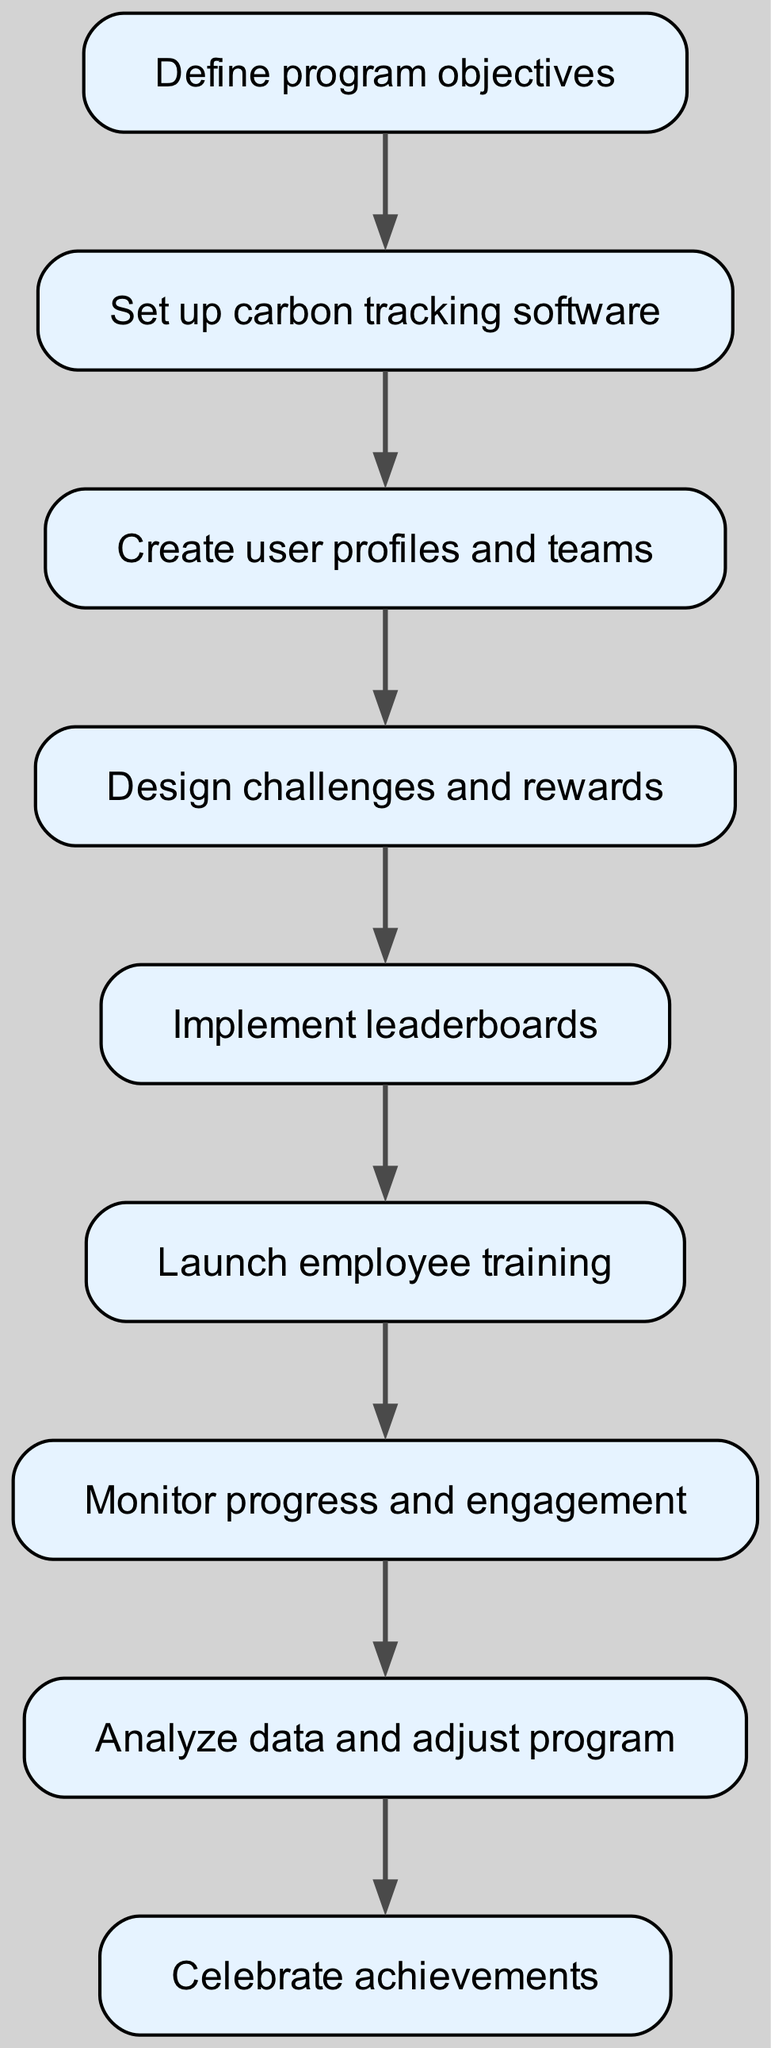What is the first step in the diagram? The first step in the diagram is labeled as "Define program objectives," which is the initial action to be taken in the process.
Answer: Define program objectives How many total steps are there in the diagram? By counting the steps listed in the diagram from the data provided, there are nine distinct steps in total outlined in the flow chart.
Answer: 9 What step comes after "Design challenges and rewards"? Following "Design challenges and rewards," the next step in the flow chart is "Implement leaderboards," indicating a progression in implementing the program.
Answer: Implement leaderboards What is the last action in the flow chart? The final action listed in the diagram is "Celebrate achievements," which is where the flow chart leads to after completing the prior steps.
Answer: Celebrate achievements Which step does directly follow "Monitor progress and engagement"? The step that comes directly after "Monitor progress and engagement" is "Analyze data and adjust program," meaning adjustments will be made based on the gathered progress.
Answer: Analyze data and adjust program What are the two consecutive steps before "Launch employee training"? The two steps preceding "Launch employee training" are "Implement leaderboards" and "Design challenges and rewards," which are focused on creating engagement tools before training employees.
Answer: Implement leaderboards, Design challenges and rewards What step connects directly to "Analyze data and adjust program"? The only step that connects directly to "Analyze data and adjust program" is "Monitor progress and engagement," showing that ongoing monitoring leads to data analysis.
Answer: Monitor progress and engagement Which steps are part of the employee engagement program? All steps included in this process, from defining objectives to celebrating achievements, are part of the engagement program aimed at reducing carbon emissions.
Answer: Define program objectives, Set up carbon tracking software, Create user profiles and teams, Design challenges and rewards, Implement leaderboards, Launch employee training, Monitor progress and engagement, Analyze data and adjust program, Celebrate achievements 